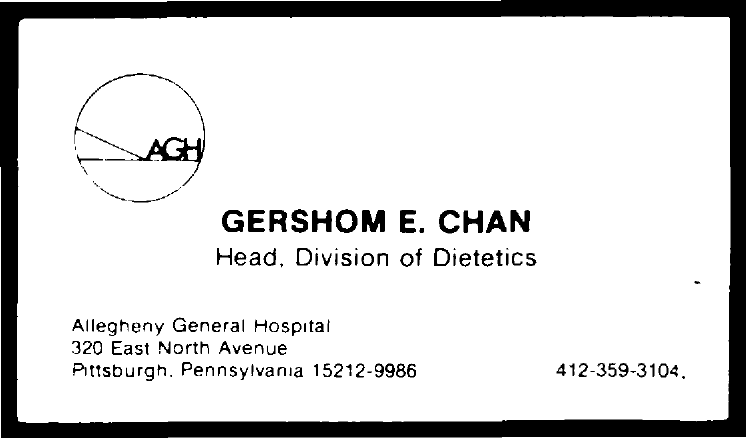Outline some significant characteristics in this image. The number located at the bottom right of the document is 3104. Gershom E. Chan is the head of the division of dietetics. The text inside the circle is AGH.. 